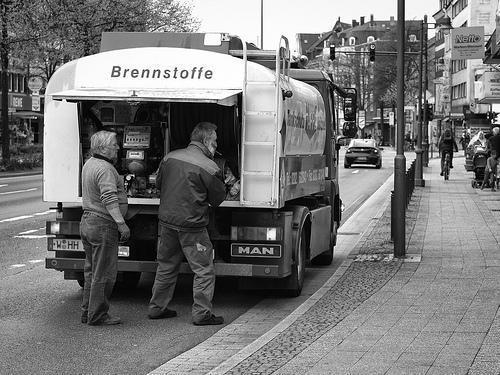How many men are by the truck?
Give a very brief answer. 2. How many men standing?
Give a very brief answer. 2. How many people are behind the truck?
Give a very brief answer. 2. How many people are riding on a sidewalk?
Give a very brief answer. 1. How many cars are on the road?
Give a very brief answer. 1. How many stoplights are on the pole?
Give a very brief answer. 2. How many trees are in this photo?
Give a very brief answer. 2. 